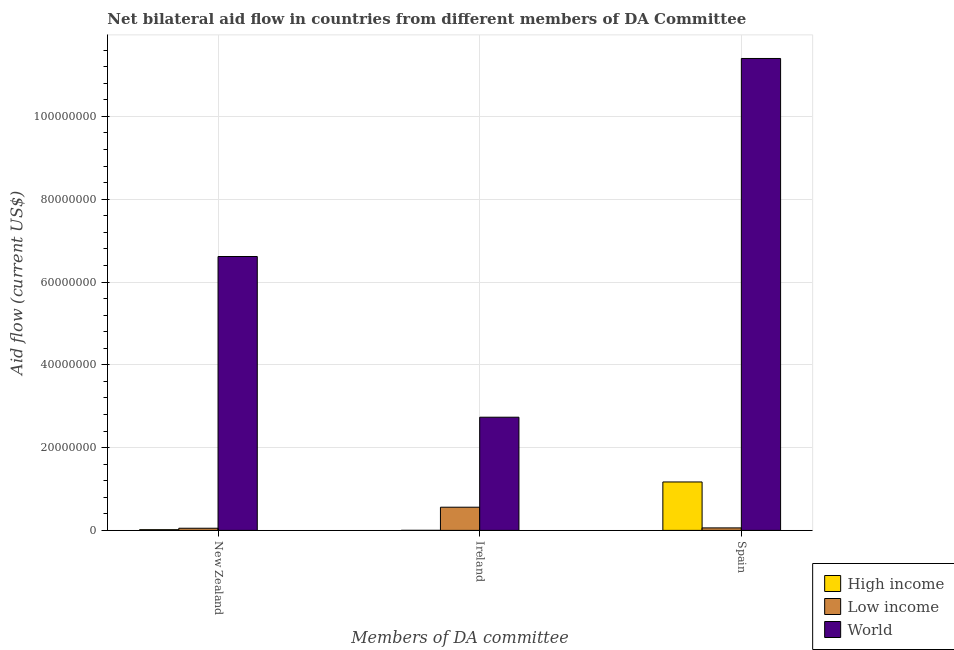How many different coloured bars are there?
Ensure brevity in your answer.  3. Are the number of bars per tick equal to the number of legend labels?
Your answer should be compact. Yes. Are the number of bars on each tick of the X-axis equal?
Offer a terse response. Yes. How many bars are there on the 2nd tick from the left?
Offer a very short reply. 3. How many bars are there on the 1st tick from the right?
Your answer should be very brief. 3. What is the label of the 3rd group of bars from the left?
Provide a short and direct response. Spain. What is the amount of aid provided by spain in Low income?
Your response must be concise. 6.00e+05. Across all countries, what is the maximum amount of aid provided by new zealand?
Offer a terse response. 6.62e+07. Across all countries, what is the minimum amount of aid provided by new zealand?
Offer a very short reply. 1.70e+05. What is the total amount of aid provided by new zealand in the graph?
Keep it short and to the point. 6.68e+07. What is the difference between the amount of aid provided by spain in Low income and that in High income?
Your answer should be compact. -1.11e+07. What is the difference between the amount of aid provided by spain in High income and the amount of aid provided by new zealand in World?
Provide a short and direct response. -5.45e+07. What is the average amount of aid provided by ireland per country?
Your answer should be compact. 1.10e+07. What is the difference between the amount of aid provided by ireland and amount of aid provided by spain in World?
Offer a very short reply. -8.67e+07. In how many countries, is the amount of aid provided by spain greater than 20000000 US$?
Provide a succinct answer. 1. What is the ratio of the amount of aid provided by spain in Low income to that in High income?
Offer a very short reply. 0.05. What is the difference between the highest and the second highest amount of aid provided by ireland?
Provide a short and direct response. 2.17e+07. What is the difference between the highest and the lowest amount of aid provided by ireland?
Your answer should be compact. 2.73e+07. Is the sum of the amount of aid provided by new zealand in High income and Low income greater than the maximum amount of aid provided by spain across all countries?
Your answer should be compact. No. What does the 3rd bar from the left in Spain represents?
Your answer should be compact. World. Does the graph contain grids?
Give a very brief answer. Yes. What is the title of the graph?
Your response must be concise. Net bilateral aid flow in countries from different members of DA Committee. What is the label or title of the X-axis?
Offer a very short reply. Members of DA committee. What is the Aid flow (current US$) of Low income in New Zealand?
Keep it short and to the point. 5.20e+05. What is the Aid flow (current US$) in World in New Zealand?
Make the answer very short. 6.62e+07. What is the Aid flow (current US$) of Low income in Ireland?
Offer a very short reply. 5.60e+06. What is the Aid flow (current US$) in World in Ireland?
Ensure brevity in your answer.  2.73e+07. What is the Aid flow (current US$) in High income in Spain?
Offer a terse response. 1.17e+07. What is the Aid flow (current US$) in World in Spain?
Offer a terse response. 1.14e+08. Across all Members of DA committee, what is the maximum Aid flow (current US$) in High income?
Keep it short and to the point. 1.17e+07. Across all Members of DA committee, what is the maximum Aid flow (current US$) of Low income?
Your answer should be compact. 5.60e+06. Across all Members of DA committee, what is the maximum Aid flow (current US$) in World?
Offer a terse response. 1.14e+08. Across all Members of DA committee, what is the minimum Aid flow (current US$) of Low income?
Your answer should be compact. 5.20e+05. Across all Members of DA committee, what is the minimum Aid flow (current US$) of World?
Your response must be concise. 2.73e+07. What is the total Aid flow (current US$) of High income in the graph?
Provide a succinct answer. 1.19e+07. What is the total Aid flow (current US$) of Low income in the graph?
Your answer should be compact. 6.72e+06. What is the total Aid flow (current US$) of World in the graph?
Give a very brief answer. 2.08e+08. What is the difference between the Aid flow (current US$) of High income in New Zealand and that in Ireland?
Make the answer very short. 1.60e+05. What is the difference between the Aid flow (current US$) of Low income in New Zealand and that in Ireland?
Offer a terse response. -5.08e+06. What is the difference between the Aid flow (current US$) in World in New Zealand and that in Ireland?
Give a very brief answer. 3.88e+07. What is the difference between the Aid flow (current US$) of High income in New Zealand and that in Spain?
Provide a short and direct response. -1.15e+07. What is the difference between the Aid flow (current US$) in Low income in New Zealand and that in Spain?
Your response must be concise. -8.00e+04. What is the difference between the Aid flow (current US$) in World in New Zealand and that in Spain?
Keep it short and to the point. -4.78e+07. What is the difference between the Aid flow (current US$) in High income in Ireland and that in Spain?
Your response must be concise. -1.17e+07. What is the difference between the Aid flow (current US$) in World in Ireland and that in Spain?
Keep it short and to the point. -8.67e+07. What is the difference between the Aid flow (current US$) of High income in New Zealand and the Aid flow (current US$) of Low income in Ireland?
Your response must be concise. -5.43e+06. What is the difference between the Aid flow (current US$) of High income in New Zealand and the Aid flow (current US$) of World in Ireland?
Ensure brevity in your answer.  -2.72e+07. What is the difference between the Aid flow (current US$) in Low income in New Zealand and the Aid flow (current US$) in World in Ireland?
Give a very brief answer. -2.68e+07. What is the difference between the Aid flow (current US$) of High income in New Zealand and the Aid flow (current US$) of Low income in Spain?
Provide a short and direct response. -4.30e+05. What is the difference between the Aid flow (current US$) in High income in New Zealand and the Aid flow (current US$) in World in Spain?
Offer a terse response. -1.14e+08. What is the difference between the Aid flow (current US$) of Low income in New Zealand and the Aid flow (current US$) of World in Spain?
Offer a very short reply. -1.13e+08. What is the difference between the Aid flow (current US$) of High income in Ireland and the Aid flow (current US$) of Low income in Spain?
Keep it short and to the point. -5.90e+05. What is the difference between the Aid flow (current US$) of High income in Ireland and the Aid flow (current US$) of World in Spain?
Offer a terse response. -1.14e+08. What is the difference between the Aid flow (current US$) of Low income in Ireland and the Aid flow (current US$) of World in Spain?
Give a very brief answer. -1.08e+08. What is the average Aid flow (current US$) of High income per Members of DA committee?
Offer a terse response. 3.96e+06. What is the average Aid flow (current US$) of Low income per Members of DA committee?
Your answer should be very brief. 2.24e+06. What is the average Aid flow (current US$) in World per Members of DA committee?
Provide a succinct answer. 6.92e+07. What is the difference between the Aid flow (current US$) in High income and Aid flow (current US$) in Low income in New Zealand?
Give a very brief answer. -3.50e+05. What is the difference between the Aid flow (current US$) of High income and Aid flow (current US$) of World in New Zealand?
Your answer should be compact. -6.60e+07. What is the difference between the Aid flow (current US$) of Low income and Aid flow (current US$) of World in New Zealand?
Your answer should be compact. -6.56e+07. What is the difference between the Aid flow (current US$) of High income and Aid flow (current US$) of Low income in Ireland?
Make the answer very short. -5.59e+06. What is the difference between the Aid flow (current US$) in High income and Aid flow (current US$) in World in Ireland?
Give a very brief answer. -2.73e+07. What is the difference between the Aid flow (current US$) of Low income and Aid flow (current US$) of World in Ireland?
Ensure brevity in your answer.  -2.17e+07. What is the difference between the Aid flow (current US$) in High income and Aid flow (current US$) in Low income in Spain?
Keep it short and to the point. 1.11e+07. What is the difference between the Aid flow (current US$) of High income and Aid flow (current US$) of World in Spain?
Provide a short and direct response. -1.02e+08. What is the difference between the Aid flow (current US$) in Low income and Aid flow (current US$) in World in Spain?
Provide a short and direct response. -1.13e+08. What is the ratio of the Aid flow (current US$) in High income in New Zealand to that in Ireland?
Make the answer very short. 17. What is the ratio of the Aid flow (current US$) in Low income in New Zealand to that in Ireland?
Offer a very short reply. 0.09. What is the ratio of the Aid flow (current US$) of World in New Zealand to that in Ireland?
Offer a very short reply. 2.42. What is the ratio of the Aid flow (current US$) in High income in New Zealand to that in Spain?
Keep it short and to the point. 0.01. What is the ratio of the Aid flow (current US$) in Low income in New Zealand to that in Spain?
Your answer should be very brief. 0.87. What is the ratio of the Aid flow (current US$) in World in New Zealand to that in Spain?
Give a very brief answer. 0.58. What is the ratio of the Aid flow (current US$) of High income in Ireland to that in Spain?
Your answer should be very brief. 0. What is the ratio of the Aid flow (current US$) in Low income in Ireland to that in Spain?
Your response must be concise. 9.33. What is the ratio of the Aid flow (current US$) of World in Ireland to that in Spain?
Provide a succinct answer. 0.24. What is the difference between the highest and the second highest Aid flow (current US$) of High income?
Make the answer very short. 1.15e+07. What is the difference between the highest and the second highest Aid flow (current US$) of Low income?
Provide a short and direct response. 5.00e+06. What is the difference between the highest and the second highest Aid flow (current US$) in World?
Offer a very short reply. 4.78e+07. What is the difference between the highest and the lowest Aid flow (current US$) in High income?
Your answer should be compact. 1.17e+07. What is the difference between the highest and the lowest Aid flow (current US$) of Low income?
Your answer should be compact. 5.08e+06. What is the difference between the highest and the lowest Aid flow (current US$) in World?
Make the answer very short. 8.67e+07. 